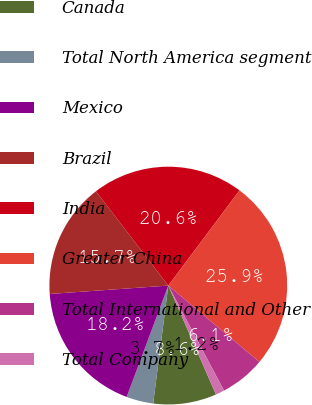Convert chart to OTSL. <chart><loc_0><loc_0><loc_500><loc_500><pie_chart><fcel>Canada<fcel>Total North America segment<fcel>Mexico<fcel>Brazil<fcel>India<fcel>Greater China<fcel>Total International and Other<fcel>Total Company<nl><fcel>8.6%<fcel>3.66%<fcel>18.18%<fcel>15.71%<fcel>20.64%<fcel>25.88%<fcel>6.13%<fcel>1.2%<nl></chart> 